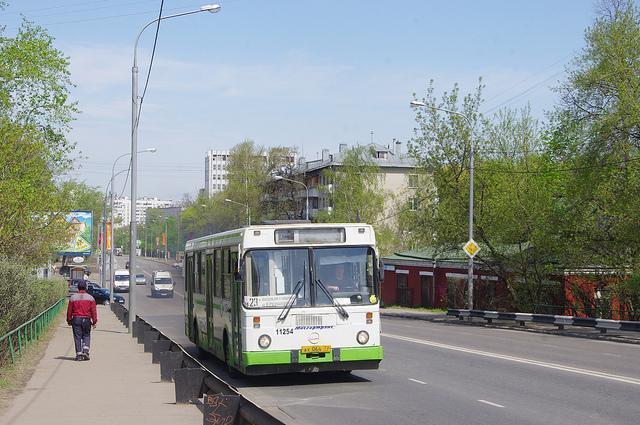Which car is in the greatest danger?
Answer the question by selecting the correct answer among the 4 following choices and explain your choice with a short sentence. The answer should be formatted with the following format: `Answer: choice
Rationale: rationale.`
Options: Grey car, white bus, black car, white truck. Answer: black car.
Rationale: The ebony car attempting to go out into the street would be the most likely to be hit in the event of an accident. 